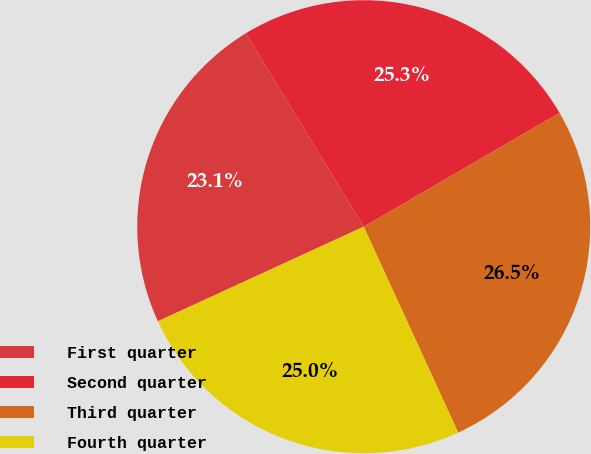<chart> <loc_0><loc_0><loc_500><loc_500><pie_chart><fcel>First quarter<fcel>Second quarter<fcel>Third quarter<fcel>Fourth quarter<nl><fcel>23.14%<fcel>25.33%<fcel>26.53%<fcel>24.99%<nl></chart> 